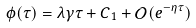<formula> <loc_0><loc_0><loc_500><loc_500>\phi ( \tau ) = \lambda \gamma \tau + C _ { 1 } + \mathcal { O } ( e ^ { - \eta \tau } )</formula> 